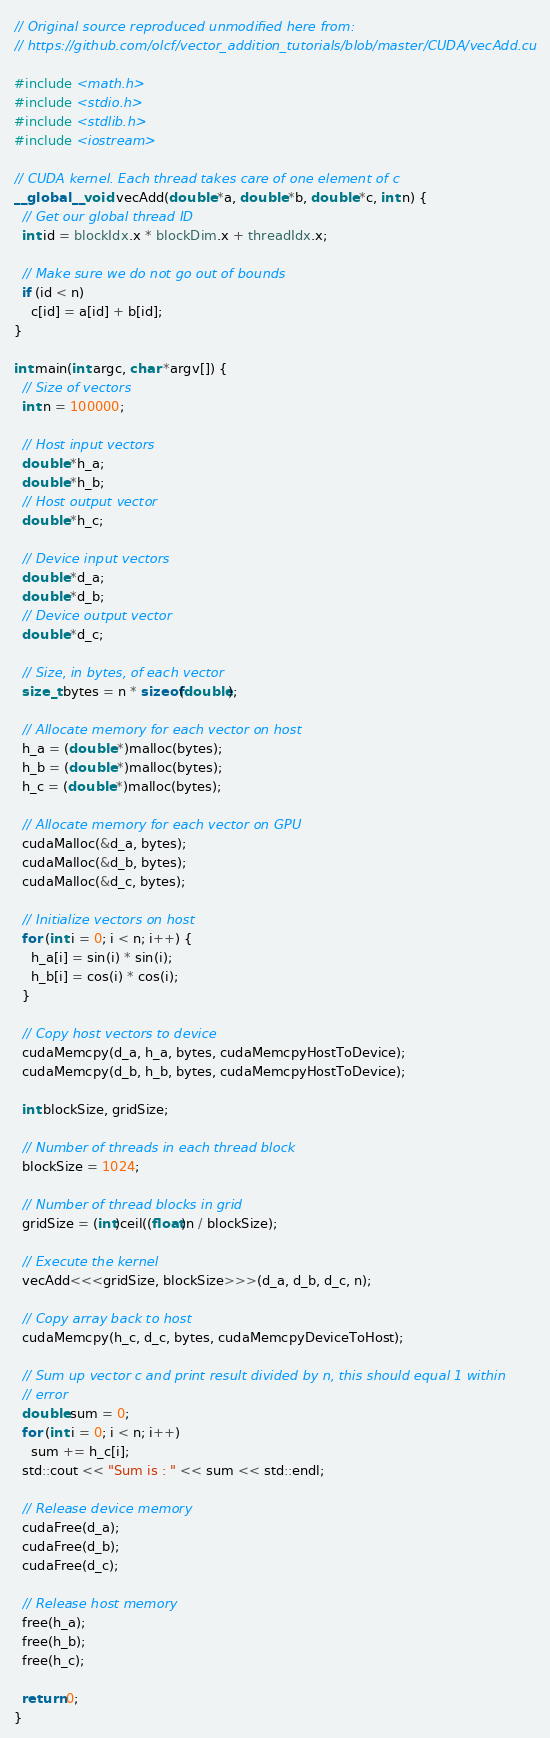Convert code to text. <code><loc_0><loc_0><loc_500><loc_500><_Cuda_>// Original source reproduced unmodified here from: 
// https://github.com/olcf/vector_addition_tutorials/blob/master/CUDA/vecAdd.cu

#include <math.h>
#include <stdio.h>
#include <stdlib.h>
#include <iostream>

// CUDA kernel. Each thread takes care of one element of c
__global__ void vecAdd(double *a, double *b, double *c, int n) {
  // Get our global thread ID
  int id = blockIdx.x * blockDim.x + threadIdx.x;

  // Make sure we do not go out of bounds
  if (id < n)
    c[id] = a[id] + b[id];
}

int main(int argc, char *argv[]) {
  // Size of vectors
  int n = 100000;

  // Host input vectors
  double *h_a;
  double *h_b;
  // Host output vector
  double *h_c;

  // Device input vectors
  double *d_a;
  double *d_b;
  // Device output vector
  double *d_c;

  // Size, in bytes, of each vector
  size_t bytes = n * sizeof(double);

  // Allocate memory for each vector on host
  h_a = (double *)malloc(bytes);
  h_b = (double *)malloc(bytes);
  h_c = (double *)malloc(bytes);

  // Allocate memory for each vector on GPU
  cudaMalloc(&d_a, bytes);
  cudaMalloc(&d_b, bytes);
  cudaMalloc(&d_c, bytes);

  // Initialize vectors on host
  for (int i = 0; i < n; i++) {
    h_a[i] = sin(i) * sin(i);
    h_b[i] = cos(i) * cos(i);
  }

  // Copy host vectors to device
  cudaMemcpy(d_a, h_a, bytes, cudaMemcpyHostToDevice);
  cudaMemcpy(d_b, h_b, bytes, cudaMemcpyHostToDevice);

  int blockSize, gridSize;

  // Number of threads in each thread block
  blockSize = 1024;

  // Number of thread blocks in grid
  gridSize = (int)ceil((float)n / blockSize);

  // Execute the kernel
  vecAdd<<<gridSize, blockSize>>>(d_a, d_b, d_c, n);

  // Copy array back to host
  cudaMemcpy(h_c, d_c, bytes, cudaMemcpyDeviceToHost);

  // Sum up vector c and print result divided by n, this should equal 1 within
  // error
  double sum = 0;
  for (int i = 0; i < n; i++)
    sum += h_c[i];
  std::cout << "Sum is : " << sum << std::endl;

  // Release device memory
  cudaFree(d_a);
  cudaFree(d_b);
  cudaFree(d_c);

  // Release host memory
  free(h_a);
  free(h_b);
  free(h_c);

  return 0;
}
</code> 